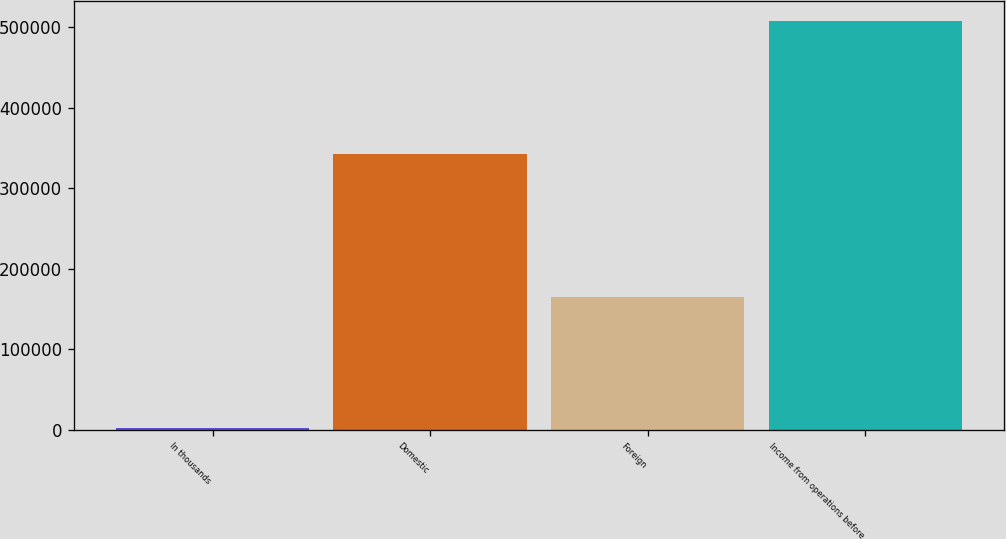Convert chart to OTSL. <chart><loc_0><loc_0><loc_500><loc_500><bar_chart><fcel>In thousands<fcel>Domestic<fcel>Foreign<fcel>Income from operations before<nl><fcel>2014<fcel>343180<fcel>164675<fcel>507855<nl></chart> 